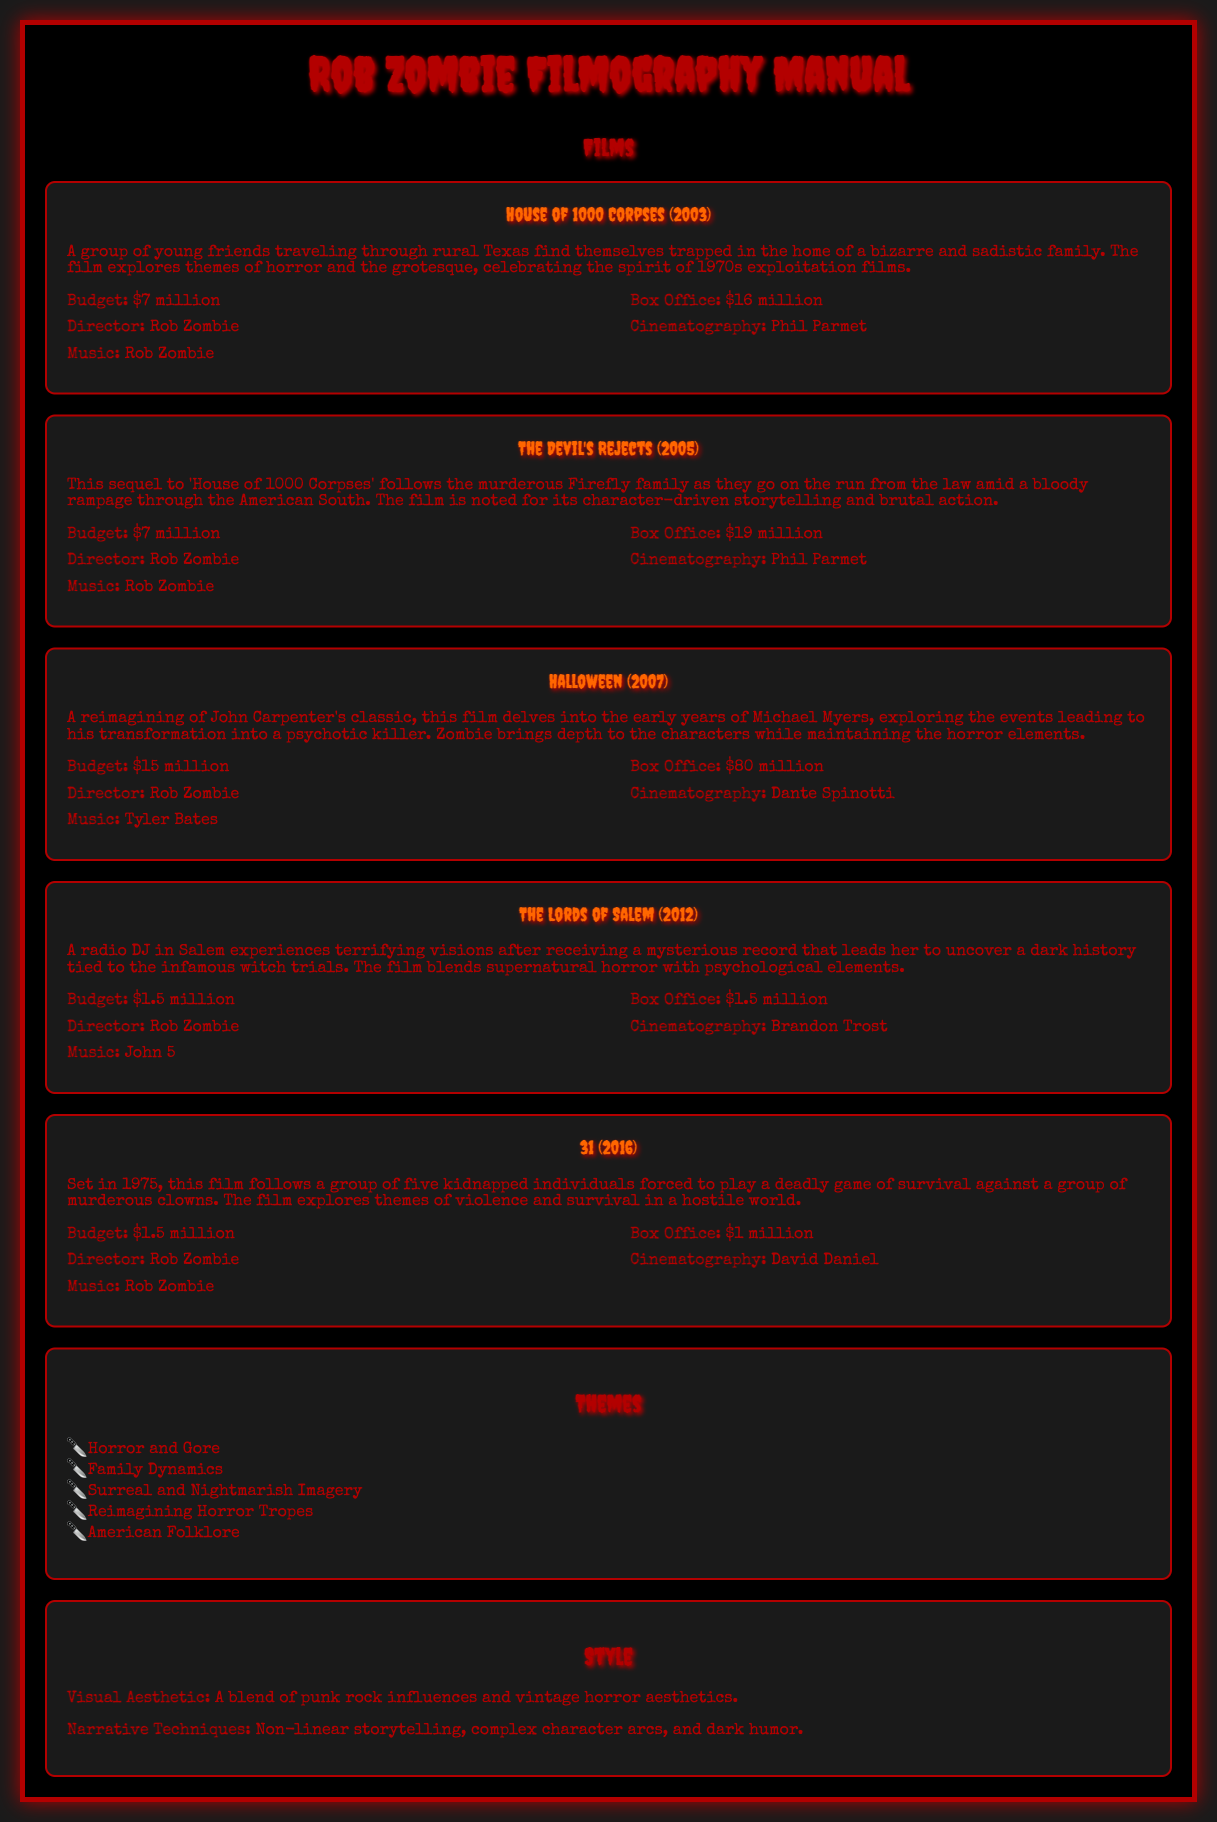What is the budget for "House of 1000 Corpses"? The budget for "House of 1000 Corpses" is specified in the production notes section of its entry.
Answer: $7 million What is the box office revenue for "Halloween"? The box office figure for "Halloween" is found in the production notes for that film.
Answer: $80 million Who directed "The Lords of Salem"? The director's name can be found in the production notes for "The Lords of Salem".
Answer: Rob Zombie What year was "31" released? The release year of "31" is stated in the film's title information.
Answer: 2016 Which film features a radio DJ in Salem? This detail about the plot can be found in the synopsis of "The Lords of Salem".
Answer: The Lords of Salem What theme is connected with the portrayal of family in Rob Zombie's films? This theme is part of the overall themes listed in the document.
Answer: Family Dynamics What is the visual aesthetic of Rob Zombie's film style? The visual aesthetic description is provided under the style section of the document.
Answer: A blend of punk rock influences and vintage horror aesthetics Which film explores the early years of Michael Myers? This detail is included in the synopsis of "Halloween".
Answer: Halloween What characterization is noted in "The Devil's Rejects"? The characterization aspect is highlighted in the synopsis of "The Devil's Rejects".
Answer: Character-driven storytelling 